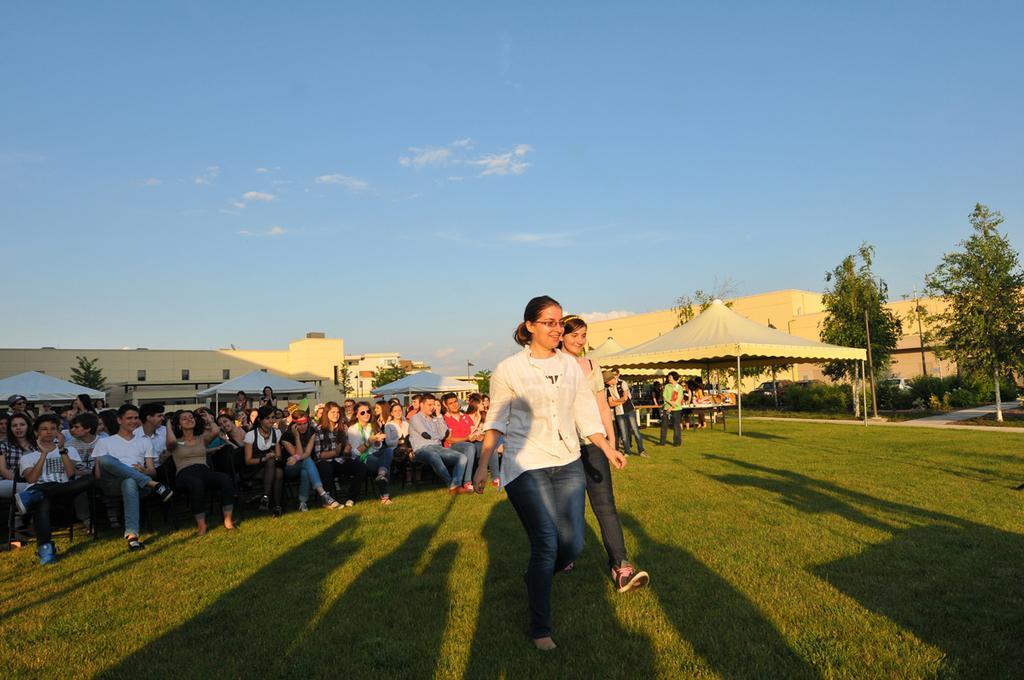In one or two sentences, can you explain what this image depicts? In this image in the front there are persons walking and smiling. In the background there are persons sitting and standing, there are tents, buildings, trees and the sky is cloudy and there is grass on the ground. 